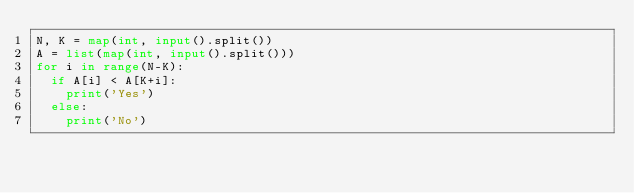Convert code to text. <code><loc_0><loc_0><loc_500><loc_500><_Python_>N, K = map(int, input().split())
A = list(map(int, input().split()))
for i in range(N-K):
  if A[i] < A[K+i]:
    print('Yes')
  else:
    print('No')</code> 